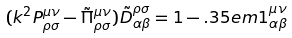<formula> <loc_0><loc_0><loc_500><loc_500>( k ^ { 2 } P _ { \rho \sigma } ^ { \mu \nu } - \tilde { \Pi } _ { \rho \sigma } ^ { \mu \nu } ) \tilde { D } _ { \alpha \beta } ^ { \rho \sigma } = 1 - . 3 5 e m 1 _ { \alpha \beta } ^ { \mu \nu }</formula> 